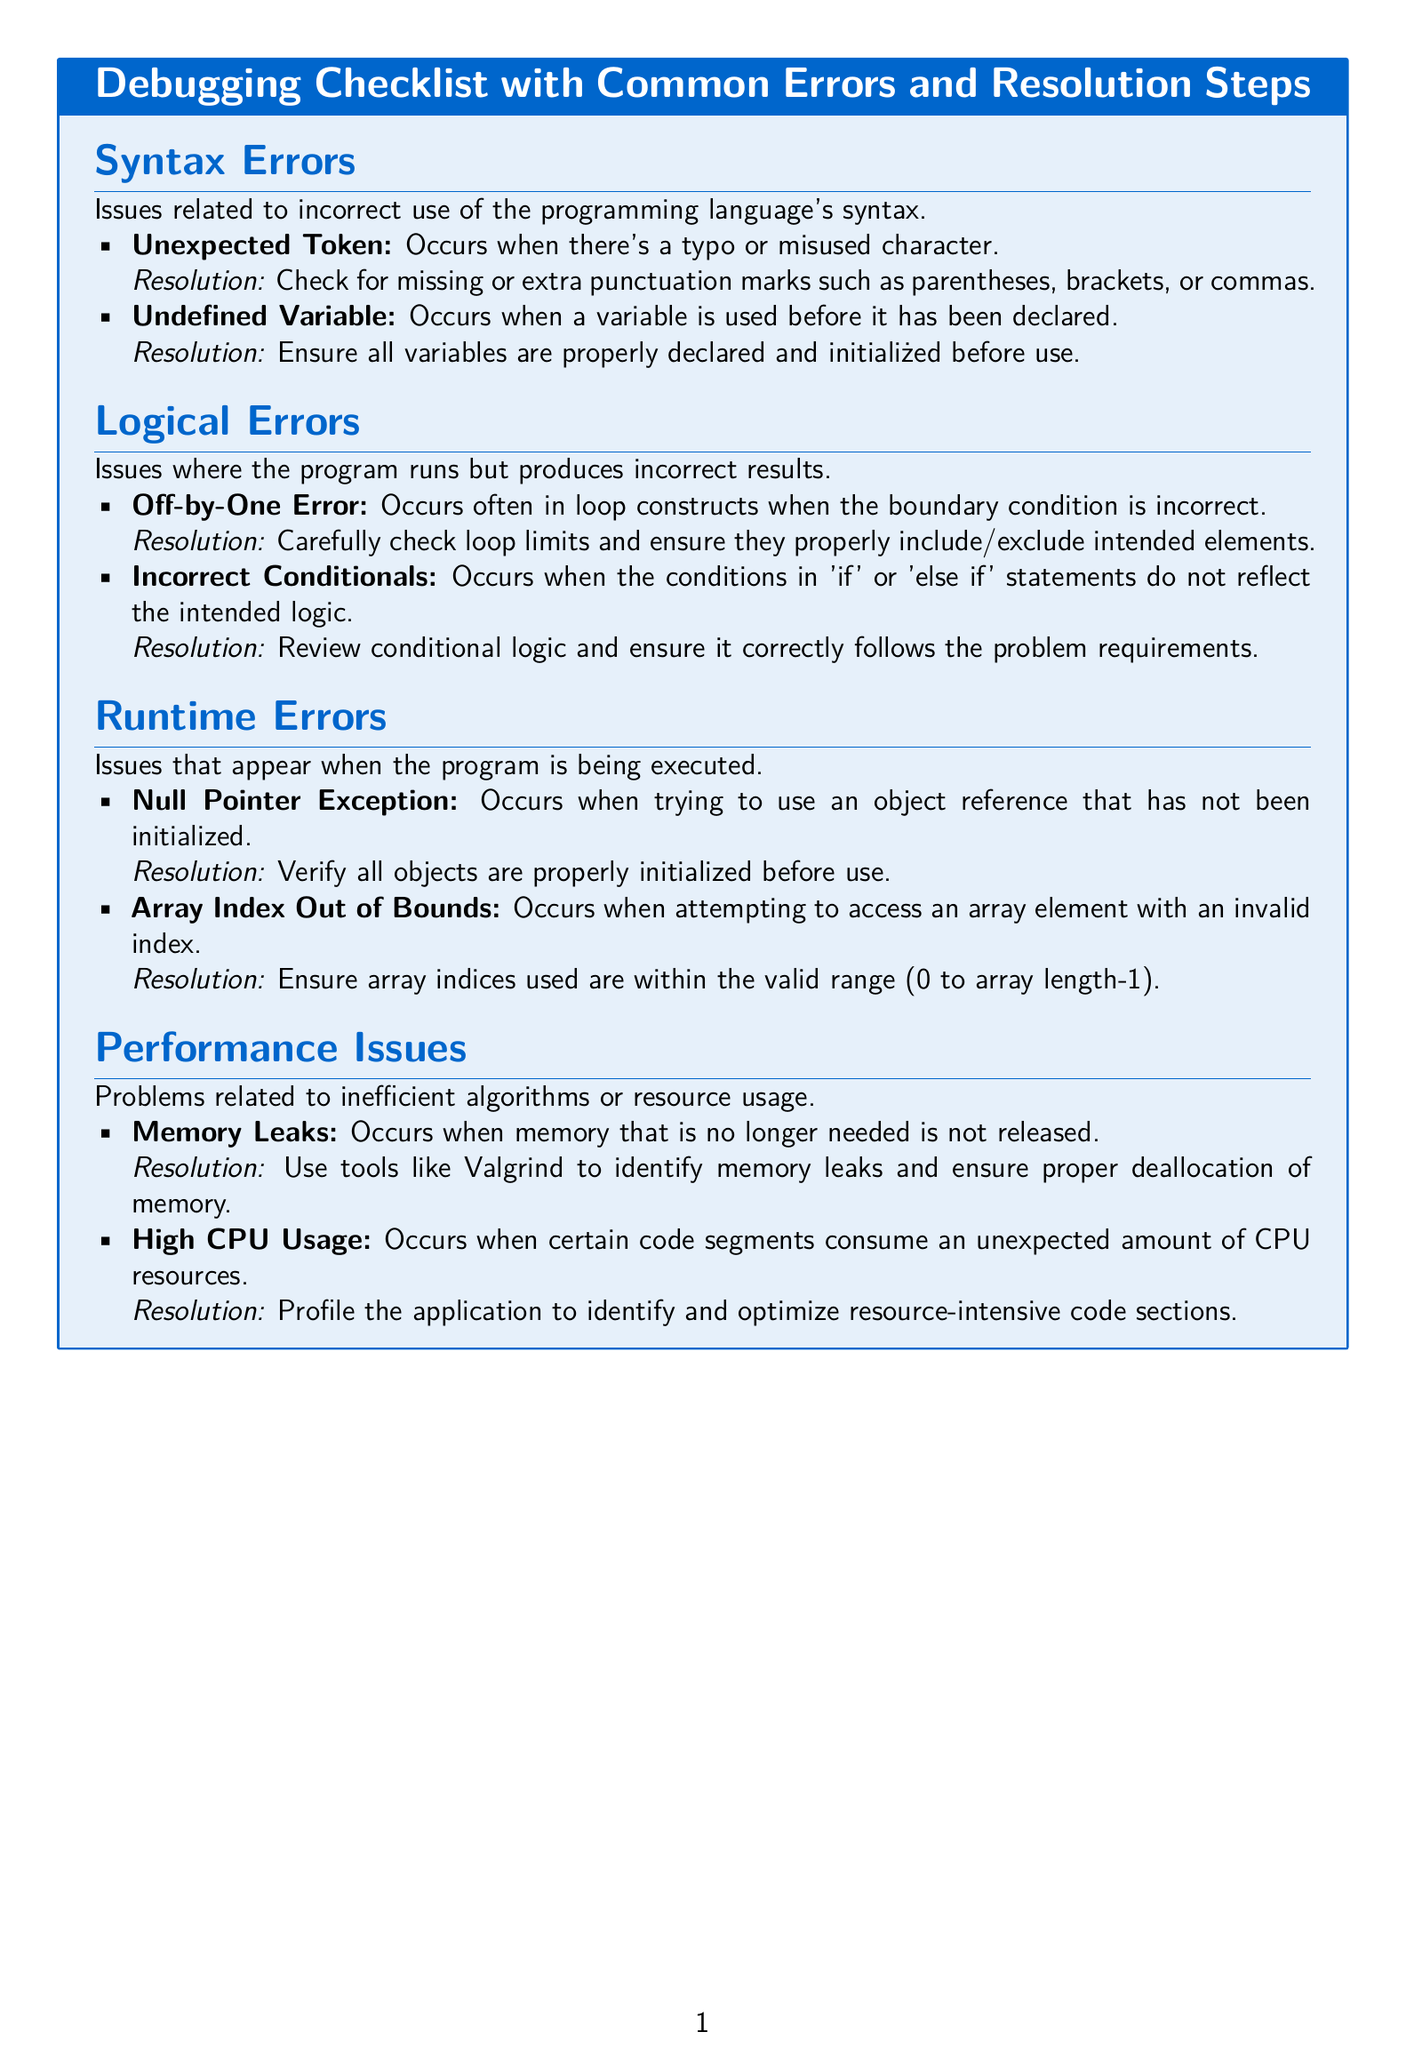What is the title of the document? The title is prominently displayed at the top of the document and reads "Debugging Checklist with Common Errors and Resolution Steps."
Answer: Debugging Checklist with Common Errors and Resolution Steps How many sections are there in the document? The document contains five sections, each addressing different types of errors.
Answer: 5 What error occurs with undefined variables? The document specifies that an Undefined Variable occurs when a variable is used before it has been declared.
Answer: Undefined Variable What resolution step is suggested for a Null Pointer Exception? The recommended resolution is to verify all objects are properly initialized before use.
Answer: Verify all objects are properly initialized What color is used for the title background? The background color of the title in the tcolorbox is white.
Answer: white What is the resolution for high CPU usage? The document advises profiling the application to identify and optimize resource-intensive code sections.
Answer: Profile the application to identify and optimize resource-intensive code sections Which error is commonly associated with loop constructs? An Off-by-One Error is mentioned as a common issue in loop constructs related to boundary conditions.
Answer: Off-by-One Error What tool is recommended for identifying memory leaks? The document suggests using tools like Valgrind for this purpose.
Answer: Valgrind 